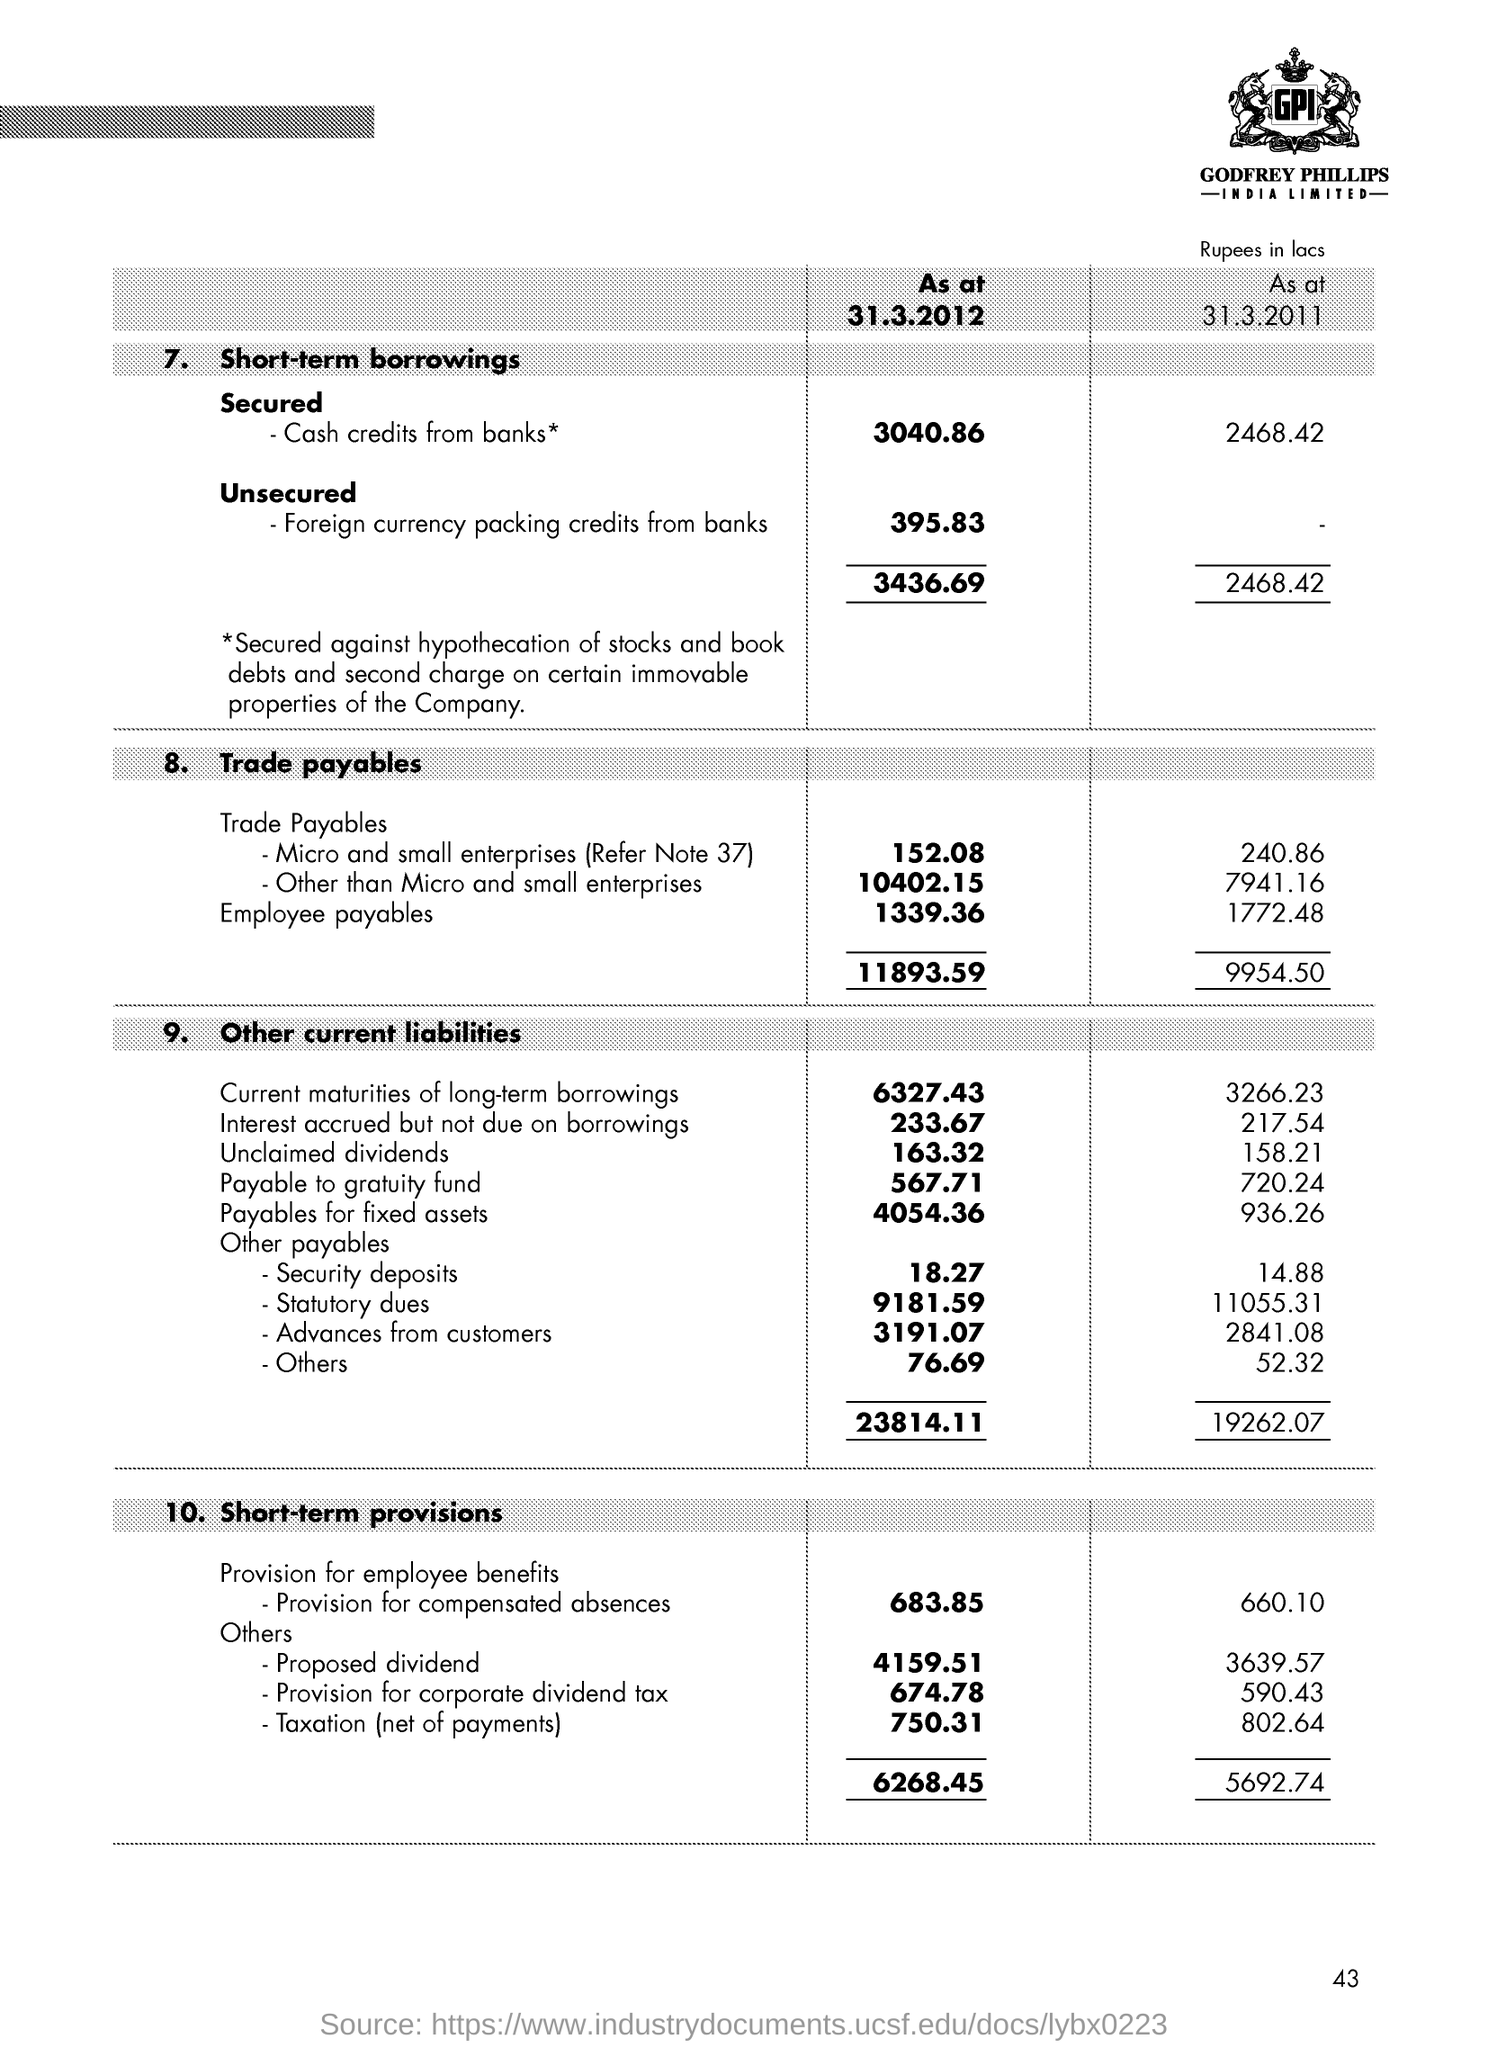List a handful of essential elements in this visual. Secured cash credit is obtained from banks. The name of the company is Godfrey Phillips. 